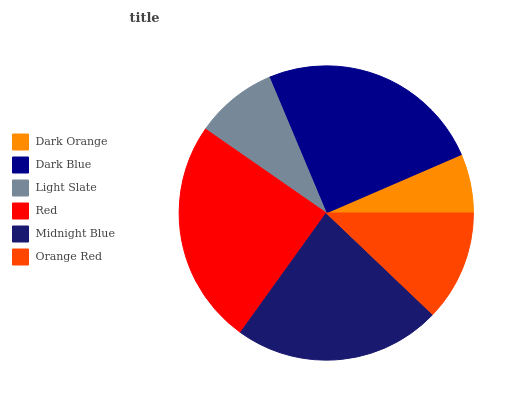Is Dark Orange the minimum?
Answer yes or no. Yes. Is Dark Blue the maximum?
Answer yes or no. Yes. Is Light Slate the minimum?
Answer yes or no. No. Is Light Slate the maximum?
Answer yes or no. No. Is Dark Blue greater than Light Slate?
Answer yes or no. Yes. Is Light Slate less than Dark Blue?
Answer yes or no. Yes. Is Light Slate greater than Dark Blue?
Answer yes or no. No. Is Dark Blue less than Light Slate?
Answer yes or no. No. Is Midnight Blue the high median?
Answer yes or no. Yes. Is Orange Red the low median?
Answer yes or no. Yes. Is Orange Red the high median?
Answer yes or no. No. Is Dark Orange the low median?
Answer yes or no. No. 